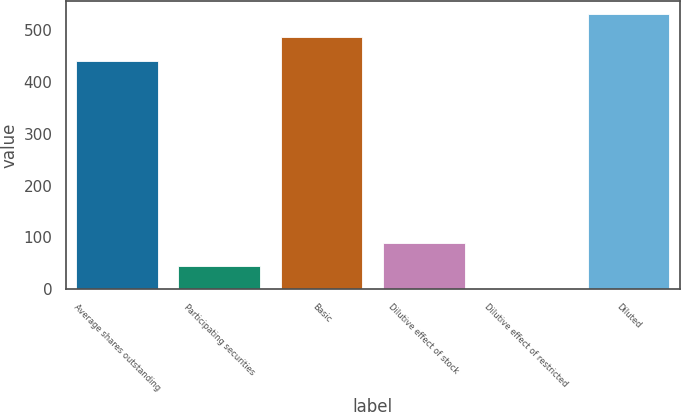Convert chart to OTSL. <chart><loc_0><loc_0><loc_500><loc_500><bar_chart><fcel>Average shares outstanding<fcel>Participating securities<fcel>Basic<fcel>Dilutive effect of stock<fcel>Dilutive effect of restricted<fcel>Diluted<nl><fcel>441.3<fcel>44.72<fcel>485.92<fcel>89.34<fcel>0.1<fcel>530.54<nl></chart> 